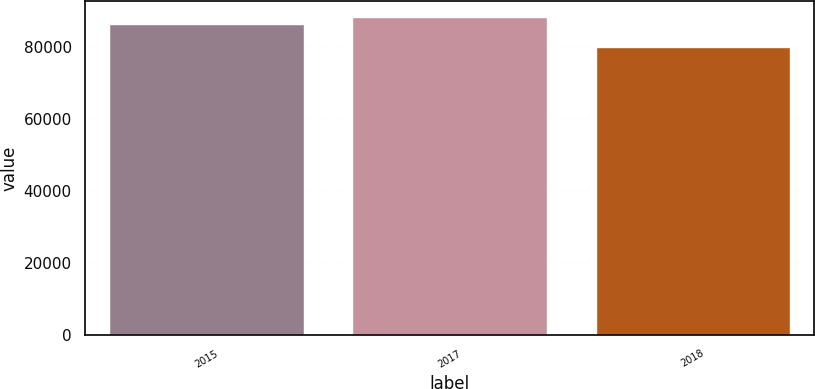Convert chart to OTSL. <chart><loc_0><loc_0><loc_500><loc_500><bar_chart><fcel>2015<fcel>2017<fcel>2018<nl><fcel>86510<fcel>88376<fcel>80068<nl></chart> 